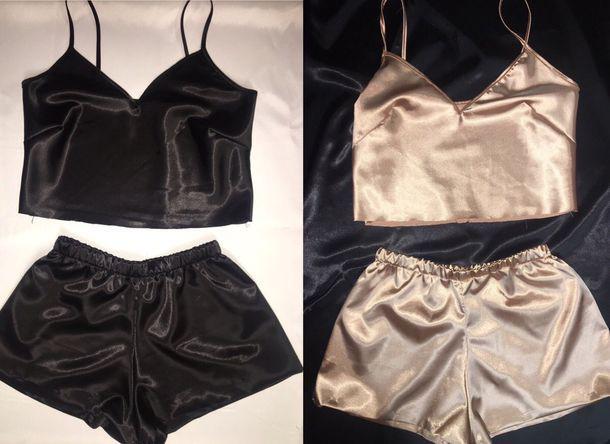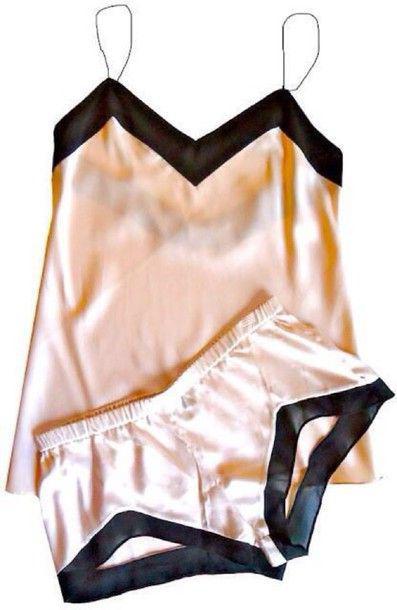The first image is the image on the left, the second image is the image on the right. Analyze the images presented: Is the assertion "There is one set of lingerie in the image on the left." valid? Answer yes or no. No. The first image is the image on the left, the second image is the image on the right. For the images displayed, is the sentence "Images feature matching dark lingerie sets and peachy colored sets, but none are worn by human models." factually correct? Answer yes or no. Yes. 